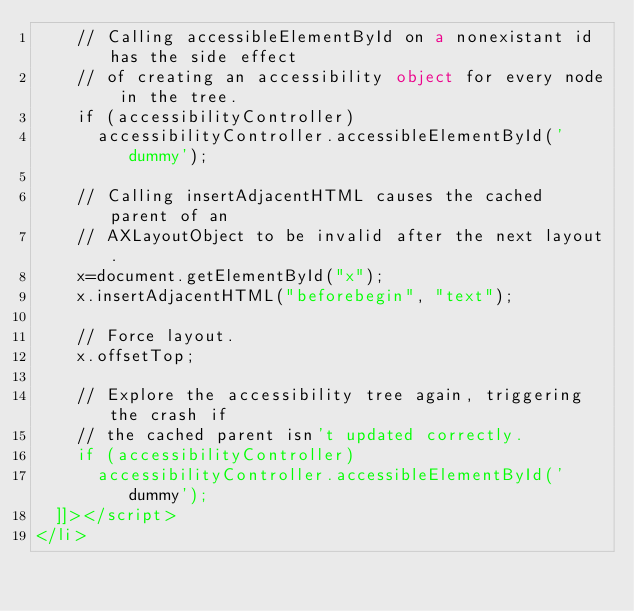Convert code to text. <code><loc_0><loc_0><loc_500><loc_500><_HTML_>    // Calling accessibleElementById on a nonexistant id has the side effect
    // of creating an accessibility object for every node in the tree.
    if (accessibilityController)
      accessibilityController.accessibleElementById('dummy');

    // Calling insertAdjacentHTML causes the cached parent of an
    // AXLayoutObject to be invalid after the next layout.
    x=document.getElementById("x");
    x.insertAdjacentHTML("beforebegin", "text");

    // Force layout.
    x.offsetTop;

    // Explore the accessibility tree again, triggering the crash if
    // the cached parent isn't updated correctly.
    if (accessibilityController)
      accessibilityController.accessibleElementById('dummy');
  ]]></script>
</li>
</code> 